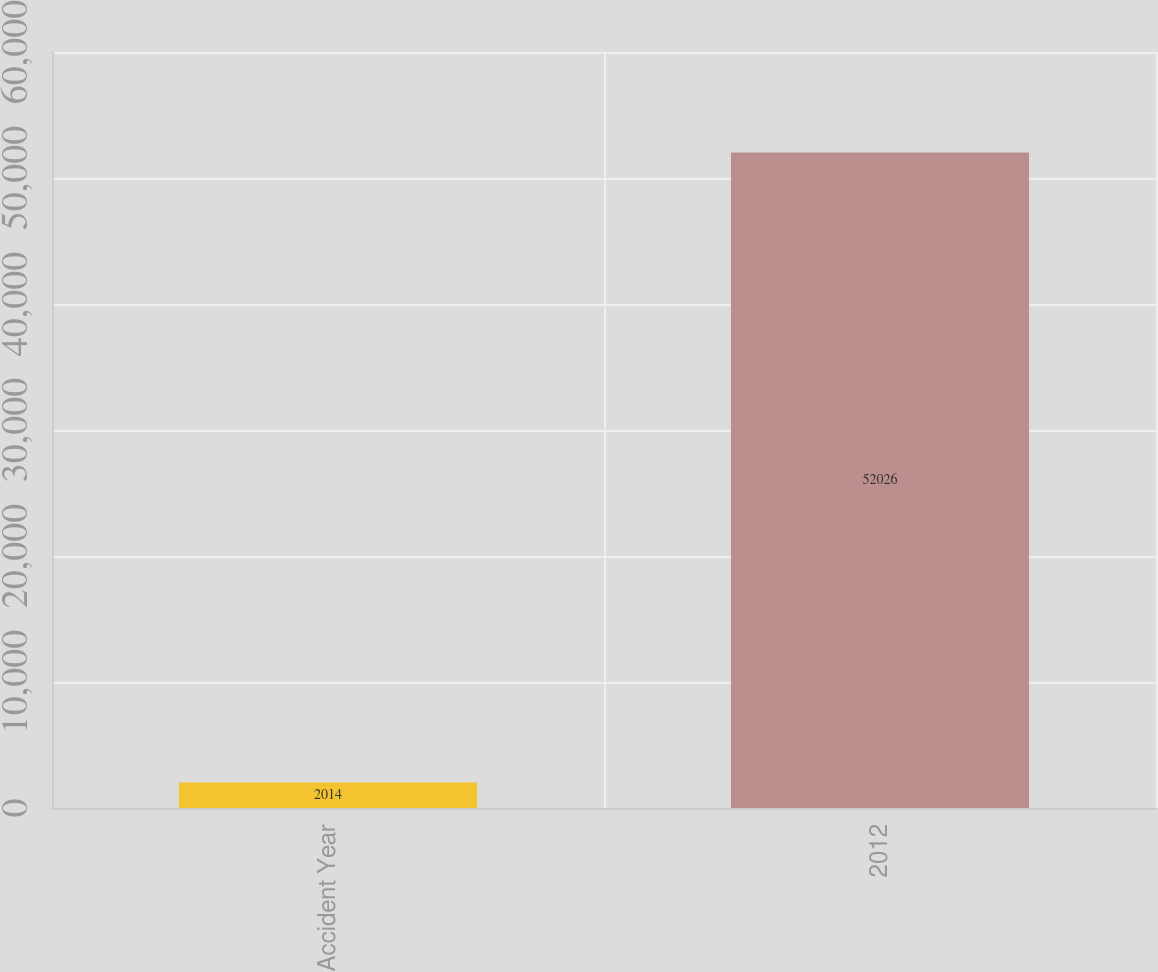Convert chart to OTSL. <chart><loc_0><loc_0><loc_500><loc_500><bar_chart><fcel>Accident Year<fcel>2012<nl><fcel>2014<fcel>52026<nl></chart> 